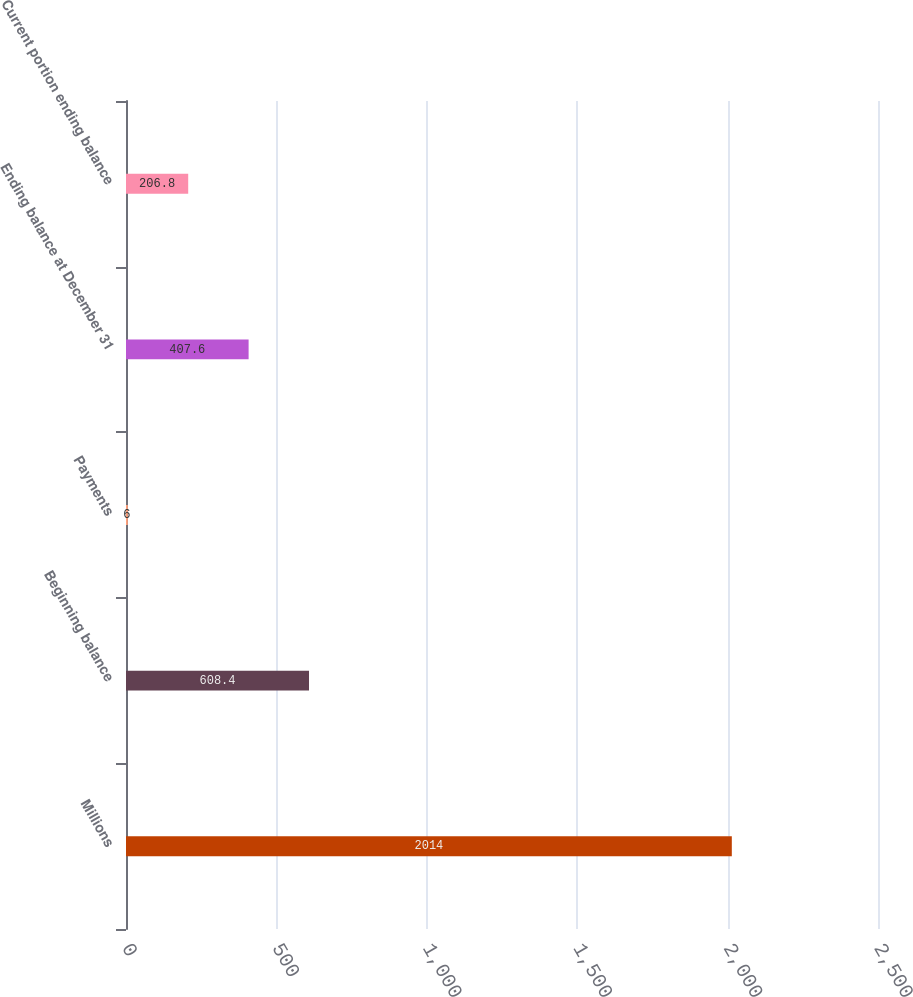Convert chart. <chart><loc_0><loc_0><loc_500><loc_500><bar_chart><fcel>Millions<fcel>Beginning balance<fcel>Payments<fcel>Ending balance at December 31<fcel>Current portion ending balance<nl><fcel>2014<fcel>608.4<fcel>6<fcel>407.6<fcel>206.8<nl></chart> 